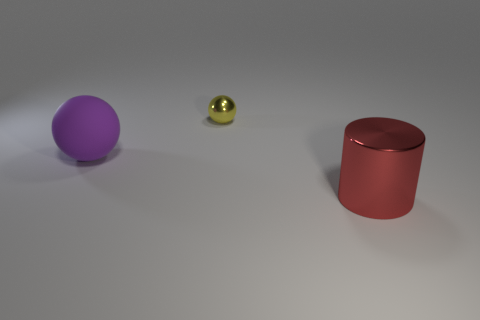There is a large purple thing that is the same shape as the tiny yellow thing; what is its material?
Your response must be concise. Rubber. Are there any other things that have the same material as the large purple ball?
Provide a short and direct response. No. What number of other things are there of the same shape as the small yellow thing?
Your response must be concise. 1. There is a shiny thing behind the big object on the right side of the metallic sphere; what number of big purple objects are behind it?
Offer a very short reply. 0. How many yellow metallic things have the same shape as the large matte object?
Provide a succinct answer. 1. Do the thing right of the tiny ball and the shiny ball have the same color?
Provide a short and direct response. No. There is a big thing that is right of the ball that is right of the big object behind the red shiny object; what is its shape?
Make the answer very short. Cylinder. There is a metal ball; is it the same size as the metallic thing that is in front of the rubber sphere?
Provide a short and direct response. No. Is there a red metallic cylinder that has the same size as the purple object?
Keep it short and to the point. Yes. What number of other things are there of the same material as the tiny yellow ball
Make the answer very short. 1. 